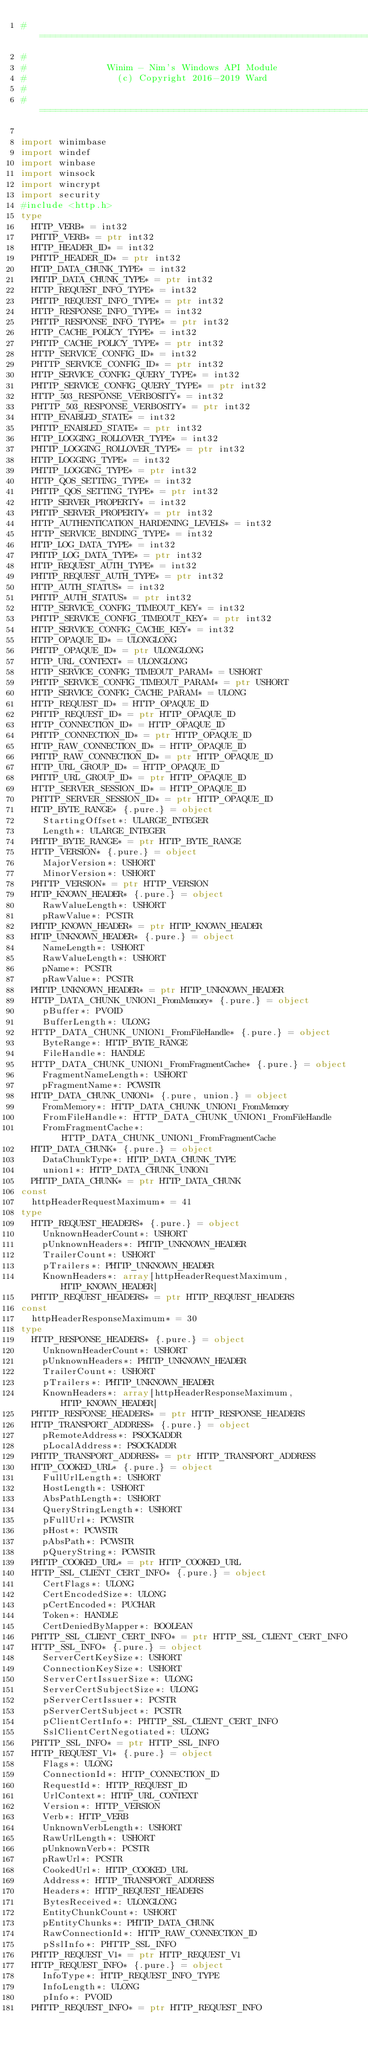Convert code to text. <code><loc_0><loc_0><loc_500><loc_500><_Nim_>#====================================================================
#
#               Winim - Nim's Windows API Module
#                 (c) Copyright 2016-2019 Ward
#
#====================================================================

import winimbase
import windef
import winbase
import winsock
import wincrypt
import security
#include <http.h>
type
  HTTP_VERB* = int32
  PHTTP_VERB* = ptr int32
  HTTP_HEADER_ID* = int32
  PHTTP_HEADER_ID* = ptr int32
  HTTP_DATA_CHUNK_TYPE* = int32
  PHTTP_DATA_CHUNK_TYPE* = ptr int32
  HTTP_REQUEST_INFO_TYPE* = int32
  PHTTP_REQUEST_INFO_TYPE* = ptr int32
  HTTP_RESPONSE_INFO_TYPE* = int32
  PHTTP_RESPONSE_INFO_TYPE* = ptr int32
  HTTP_CACHE_POLICY_TYPE* = int32
  PHTTP_CACHE_POLICY_TYPE* = ptr int32
  HTTP_SERVICE_CONFIG_ID* = int32
  PHTTP_SERVICE_CONFIG_ID* = ptr int32
  HTTP_SERVICE_CONFIG_QUERY_TYPE* = int32
  PHTTP_SERVICE_CONFIG_QUERY_TYPE* = ptr int32
  HTTP_503_RESPONSE_VERBOSITY* = int32
  PHTTP_503_RESPONSE_VERBOSITY* = ptr int32
  HTTP_ENABLED_STATE* = int32
  PHTTP_ENABLED_STATE* = ptr int32
  HTTP_LOGGING_ROLLOVER_TYPE* = int32
  PHTTP_LOGGING_ROLLOVER_TYPE* = ptr int32
  HTTP_LOGGING_TYPE* = int32
  PHTTP_LOGGING_TYPE* = ptr int32
  HTTP_QOS_SETTING_TYPE* = int32
  PHTTP_QOS_SETTING_TYPE* = ptr int32
  HTTP_SERVER_PROPERTY* = int32
  PHTTP_SERVER_PROPERTY* = ptr int32
  HTTP_AUTHENTICATION_HARDENING_LEVELS* = int32
  HTTP_SERVICE_BINDING_TYPE* = int32
  HTTP_LOG_DATA_TYPE* = int32
  PHTTP_LOG_DATA_TYPE* = ptr int32
  HTTP_REQUEST_AUTH_TYPE* = int32
  PHTTP_REQUEST_AUTH_TYPE* = ptr int32
  HTTP_AUTH_STATUS* = int32
  PHTTP_AUTH_STATUS* = ptr int32
  HTTP_SERVICE_CONFIG_TIMEOUT_KEY* = int32
  PHTTP_SERVICE_CONFIG_TIMEOUT_KEY* = ptr int32
  HTTP_SERVICE_CONFIG_CACHE_KEY* = int32
  HTTP_OPAQUE_ID* = ULONGLONG
  PHTTP_OPAQUE_ID* = ptr ULONGLONG
  HTTP_URL_CONTEXT* = ULONGLONG
  HTTP_SERVICE_CONFIG_TIMEOUT_PARAM* = USHORT
  PHTTP_SERVICE_CONFIG_TIMEOUT_PARAM* = ptr USHORT
  HTTP_SERVICE_CONFIG_CACHE_PARAM* = ULONG
  HTTP_REQUEST_ID* = HTTP_OPAQUE_ID
  PHTTP_REQUEST_ID* = ptr HTTP_OPAQUE_ID
  HTTP_CONNECTION_ID* = HTTP_OPAQUE_ID
  PHTTP_CONNECTION_ID* = ptr HTTP_OPAQUE_ID
  HTTP_RAW_CONNECTION_ID* = HTTP_OPAQUE_ID
  PHTTP_RAW_CONNECTION_ID* = ptr HTTP_OPAQUE_ID
  HTTP_URL_GROUP_ID* = HTTP_OPAQUE_ID
  PHTTP_URL_GROUP_ID* = ptr HTTP_OPAQUE_ID
  HTTP_SERVER_SESSION_ID* = HTTP_OPAQUE_ID
  PHTTP_SERVER_SESSION_ID* = ptr HTTP_OPAQUE_ID
  HTTP_BYTE_RANGE* {.pure.} = object
    StartingOffset*: ULARGE_INTEGER
    Length*: ULARGE_INTEGER
  PHTTP_BYTE_RANGE* = ptr HTTP_BYTE_RANGE
  HTTP_VERSION* {.pure.} = object
    MajorVersion*: USHORT
    MinorVersion*: USHORT
  PHTTP_VERSION* = ptr HTTP_VERSION
  HTTP_KNOWN_HEADER* {.pure.} = object
    RawValueLength*: USHORT
    pRawValue*: PCSTR
  PHTTP_KNOWN_HEADER* = ptr HTTP_KNOWN_HEADER
  HTTP_UNKNOWN_HEADER* {.pure.} = object
    NameLength*: USHORT
    RawValueLength*: USHORT
    pName*: PCSTR
    pRawValue*: PCSTR
  PHTTP_UNKNOWN_HEADER* = ptr HTTP_UNKNOWN_HEADER
  HTTP_DATA_CHUNK_UNION1_FromMemory* {.pure.} = object
    pBuffer*: PVOID
    BufferLength*: ULONG
  HTTP_DATA_CHUNK_UNION1_FromFileHandle* {.pure.} = object
    ByteRange*: HTTP_BYTE_RANGE
    FileHandle*: HANDLE
  HTTP_DATA_CHUNK_UNION1_FromFragmentCache* {.pure.} = object
    FragmentNameLength*: USHORT
    pFragmentName*: PCWSTR
  HTTP_DATA_CHUNK_UNION1* {.pure, union.} = object
    FromMemory*: HTTP_DATA_CHUNK_UNION1_FromMemory
    FromFileHandle*: HTTP_DATA_CHUNK_UNION1_FromFileHandle
    FromFragmentCache*: HTTP_DATA_CHUNK_UNION1_FromFragmentCache
  HTTP_DATA_CHUNK* {.pure.} = object
    DataChunkType*: HTTP_DATA_CHUNK_TYPE
    union1*: HTTP_DATA_CHUNK_UNION1
  PHTTP_DATA_CHUNK* = ptr HTTP_DATA_CHUNK
const
  httpHeaderRequestMaximum* = 41
type
  HTTP_REQUEST_HEADERS* {.pure.} = object
    UnknownHeaderCount*: USHORT
    pUnknownHeaders*: PHTTP_UNKNOWN_HEADER
    TrailerCount*: USHORT
    pTrailers*: PHTTP_UNKNOWN_HEADER
    KnownHeaders*: array[httpHeaderRequestMaximum, HTTP_KNOWN_HEADER]
  PHTTP_REQUEST_HEADERS* = ptr HTTP_REQUEST_HEADERS
const
  httpHeaderResponseMaximum* = 30
type
  HTTP_RESPONSE_HEADERS* {.pure.} = object
    UnknownHeaderCount*: USHORT
    pUnknownHeaders*: PHTTP_UNKNOWN_HEADER
    TrailerCount*: USHORT
    pTrailers*: PHTTP_UNKNOWN_HEADER
    KnownHeaders*: array[httpHeaderResponseMaximum, HTTP_KNOWN_HEADER]
  PHTTP_RESPONSE_HEADERS* = ptr HTTP_RESPONSE_HEADERS
  HTTP_TRANSPORT_ADDRESS* {.pure.} = object
    pRemoteAddress*: PSOCKADDR
    pLocalAddress*: PSOCKADDR
  PHTTP_TRANSPORT_ADDRESS* = ptr HTTP_TRANSPORT_ADDRESS
  HTTP_COOKED_URL* {.pure.} = object
    FullUrlLength*: USHORT
    HostLength*: USHORT
    AbsPathLength*: USHORT
    QueryStringLength*: USHORT
    pFullUrl*: PCWSTR
    pHost*: PCWSTR
    pAbsPath*: PCWSTR
    pQueryString*: PCWSTR
  PHTTP_COOKED_URL* = ptr HTTP_COOKED_URL
  HTTP_SSL_CLIENT_CERT_INFO* {.pure.} = object
    CertFlags*: ULONG
    CertEncodedSize*: ULONG
    pCertEncoded*: PUCHAR
    Token*: HANDLE
    CertDeniedByMapper*: BOOLEAN
  PHTTP_SSL_CLIENT_CERT_INFO* = ptr HTTP_SSL_CLIENT_CERT_INFO
  HTTP_SSL_INFO* {.pure.} = object
    ServerCertKeySize*: USHORT
    ConnectionKeySize*: USHORT
    ServerCertIssuerSize*: ULONG
    ServerCertSubjectSize*: ULONG
    pServerCertIssuer*: PCSTR
    pServerCertSubject*: PCSTR
    pClientCertInfo*: PHTTP_SSL_CLIENT_CERT_INFO
    SslClientCertNegotiated*: ULONG
  PHTTP_SSL_INFO* = ptr HTTP_SSL_INFO
  HTTP_REQUEST_V1* {.pure.} = object
    Flags*: ULONG
    ConnectionId*: HTTP_CONNECTION_ID
    RequestId*: HTTP_REQUEST_ID
    UrlContext*: HTTP_URL_CONTEXT
    Version*: HTTP_VERSION
    Verb*: HTTP_VERB
    UnknownVerbLength*: USHORT
    RawUrlLength*: USHORT
    pUnknownVerb*: PCSTR
    pRawUrl*: PCSTR
    CookedUrl*: HTTP_COOKED_URL
    Address*: HTTP_TRANSPORT_ADDRESS
    Headers*: HTTP_REQUEST_HEADERS
    BytesReceived*: ULONGLONG
    EntityChunkCount*: USHORT
    pEntityChunks*: PHTTP_DATA_CHUNK
    RawConnectionId*: HTTP_RAW_CONNECTION_ID
    pSslInfo*: PHTTP_SSL_INFO
  PHTTP_REQUEST_V1* = ptr HTTP_REQUEST_V1
  HTTP_REQUEST_INFO* {.pure.} = object
    InfoType*: HTTP_REQUEST_INFO_TYPE
    InfoLength*: ULONG
    pInfo*: PVOID
  PHTTP_REQUEST_INFO* = ptr HTTP_REQUEST_INFO</code> 